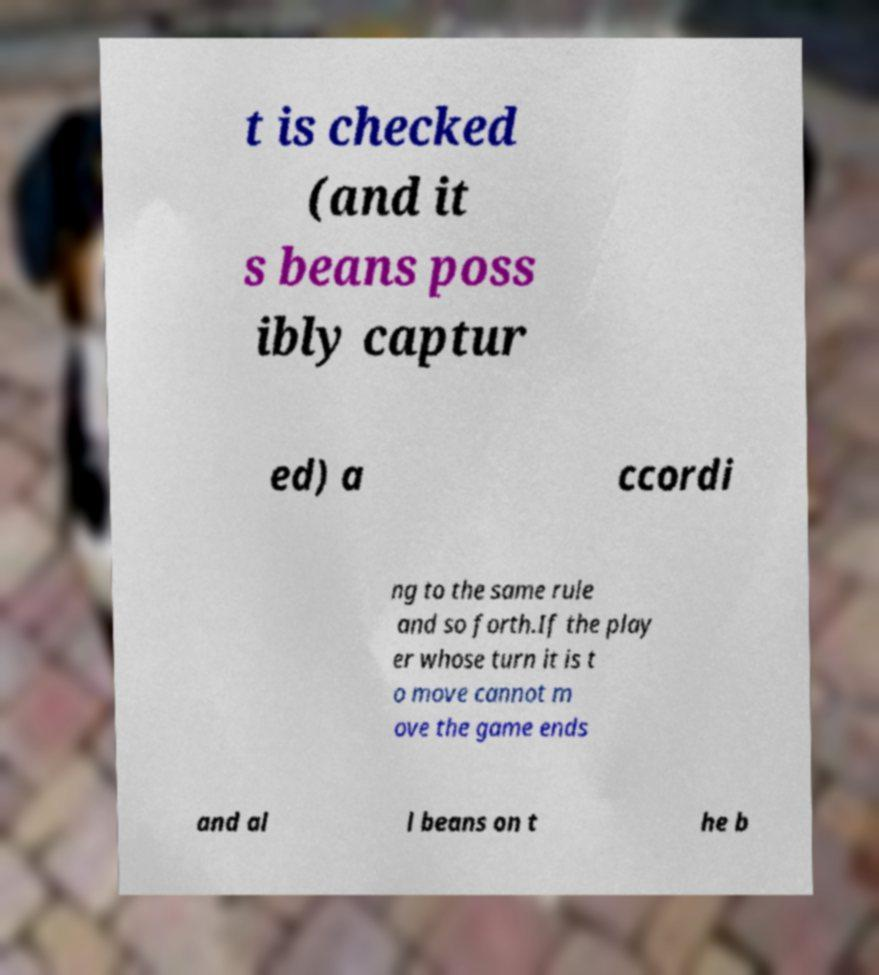Could you assist in decoding the text presented in this image and type it out clearly? t is checked (and it s beans poss ibly captur ed) a ccordi ng to the same rule and so forth.If the play er whose turn it is t o move cannot m ove the game ends and al l beans on t he b 